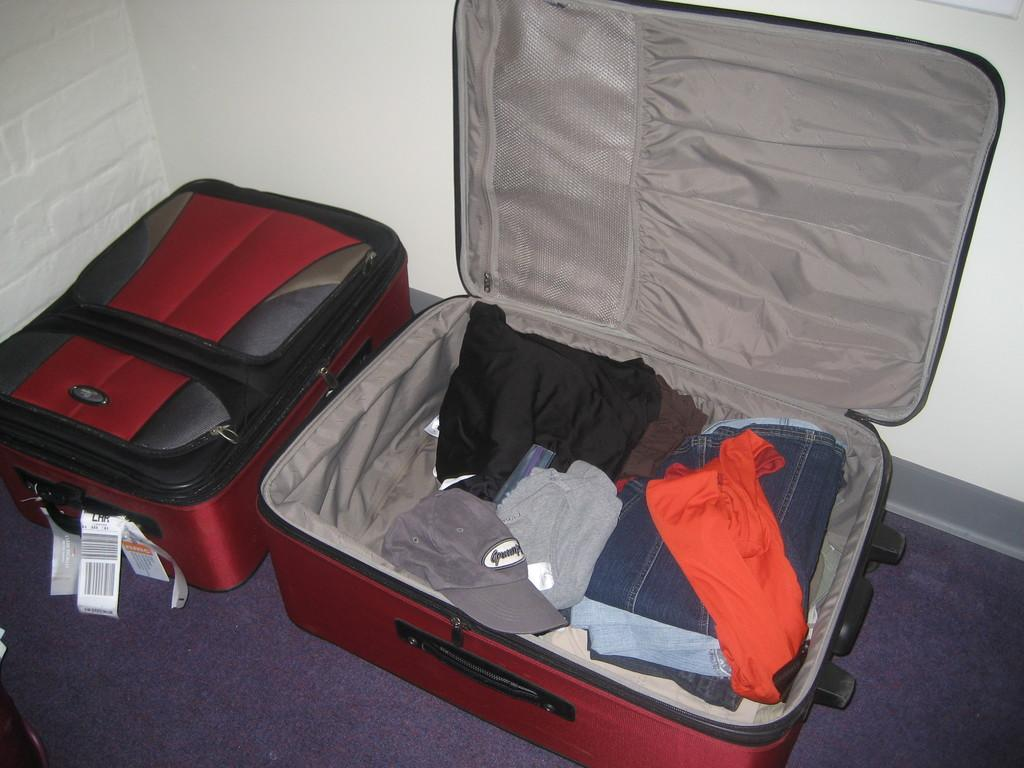How many trolley bags are visible in the image? There are two trolley bags in the image. What is the difference between the two trolley bags? One trolley bag is closed, and the other is opened. What can be found inside one of the trolley bags? There are clothes in one of the trolley bags. What color is the wall in the image? The wall in the image is painted white. What type of tail can be seen on the maid in the image? There is no maid or tail present in the image. What season is depicted in the image? The provided facts do not mention any season or weather-related details, so it cannot be determined from the image. 